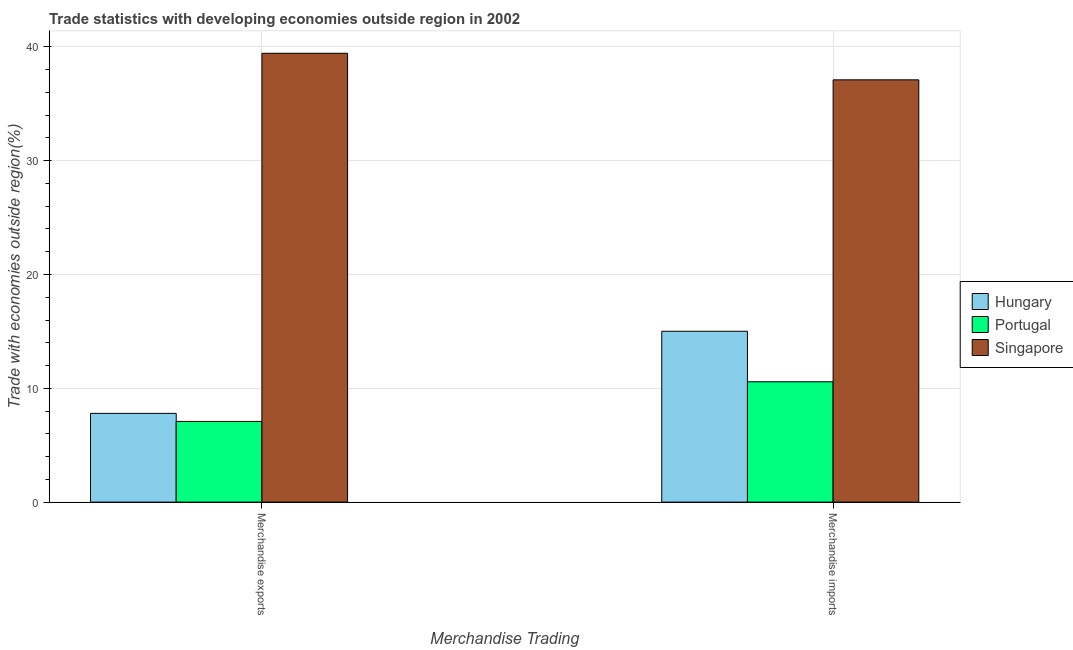How many groups of bars are there?
Keep it short and to the point. 2. Are the number of bars per tick equal to the number of legend labels?
Your answer should be very brief. Yes. How many bars are there on the 2nd tick from the left?
Provide a short and direct response. 3. How many bars are there on the 1st tick from the right?
Make the answer very short. 3. What is the merchandise exports in Hungary?
Your answer should be compact. 7.8. Across all countries, what is the maximum merchandise imports?
Make the answer very short. 37.1. Across all countries, what is the minimum merchandise imports?
Offer a very short reply. 10.57. In which country was the merchandise exports maximum?
Make the answer very short. Singapore. In which country was the merchandise exports minimum?
Your answer should be very brief. Portugal. What is the total merchandise imports in the graph?
Offer a very short reply. 62.69. What is the difference between the merchandise exports in Hungary and that in Portugal?
Offer a very short reply. 0.71. What is the difference between the merchandise imports in Portugal and the merchandise exports in Hungary?
Offer a terse response. 2.78. What is the average merchandise exports per country?
Make the answer very short. 18.11. What is the difference between the merchandise exports and merchandise imports in Hungary?
Ensure brevity in your answer.  -7.21. In how many countries, is the merchandise imports greater than 26 %?
Make the answer very short. 1. What is the ratio of the merchandise imports in Singapore to that in Portugal?
Keep it short and to the point. 3.51. Is the merchandise exports in Hungary less than that in Singapore?
Offer a terse response. Yes. In how many countries, is the merchandise exports greater than the average merchandise exports taken over all countries?
Ensure brevity in your answer.  1. What does the 1st bar from the left in Merchandise exports represents?
Offer a terse response. Hungary. How many bars are there?
Offer a very short reply. 6. Are all the bars in the graph horizontal?
Keep it short and to the point. No. How many countries are there in the graph?
Keep it short and to the point. 3. Are the values on the major ticks of Y-axis written in scientific E-notation?
Make the answer very short. No. Where does the legend appear in the graph?
Offer a terse response. Center right. What is the title of the graph?
Give a very brief answer. Trade statistics with developing economies outside region in 2002. Does "Isle of Man" appear as one of the legend labels in the graph?
Your answer should be compact. No. What is the label or title of the X-axis?
Make the answer very short. Merchandise Trading. What is the label or title of the Y-axis?
Your response must be concise. Trade with economies outside region(%). What is the Trade with economies outside region(%) in Hungary in Merchandise exports?
Your answer should be very brief. 7.8. What is the Trade with economies outside region(%) of Portugal in Merchandise exports?
Provide a succinct answer. 7.09. What is the Trade with economies outside region(%) of Singapore in Merchandise exports?
Offer a very short reply. 39.44. What is the Trade with economies outside region(%) of Hungary in Merchandise imports?
Offer a very short reply. 15.01. What is the Trade with economies outside region(%) of Portugal in Merchandise imports?
Give a very brief answer. 10.57. What is the Trade with economies outside region(%) in Singapore in Merchandise imports?
Give a very brief answer. 37.1. Across all Merchandise Trading, what is the maximum Trade with economies outside region(%) of Hungary?
Your answer should be very brief. 15.01. Across all Merchandise Trading, what is the maximum Trade with economies outside region(%) in Portugal?
Offer a very short reply. 10.57. Across all Merchandise Trading, what is the maximum Trade with economies outside region(%) in Singapore?
Your response must be concise. 39.44. Across all Merchandise Trading, what is the minimum Trade with economies outside region(%) of Hungary?
Provide a short and direct response. 7.8. Across all Merchandise Trading, what is the minimum Trade with economies outside region(%) of Portugal?
Provide a succinct answer. 7.09. Across all Merchandise Trading, what is the minimum Trade with economies outside region(%) in Singapore?
Ensure brevity in your answer.  37.1. What is the total Trade with economies outside region(%) of Hungary in the graph?
Keep it short and to the point. 22.81. What is the total Trade with economies outside region(%) in Portugal in the graph?
Keep it short and to the point. 17.66. What is the total Trade with economies outside region(%) of Singapore in the graph?
Offer a terse response. 76.54. What is the difference between the Trade with economies outside region(%) of Hungary in Merchandise exports and that in Merchandise imports?
Offer a very short reply. -7.21. What is the difference between the Trade with economies outside region(%) in Portugal in Merchandise exports and that in Merchandise imports?
Provide a succinct answer. -3.48. What is the difference between the Trade with economies outside region(%) in Singapore in Merchandise exports and that in Merchandise imports?
Keep it short and to the point. 2.33. What is the difference between the Trade with economies outside region(%) of Hungary in Merchandise exports and the Trade with economies outside region(%) of Portugal in Merchandise imports?
Your answer should be very brief. -2.78. What is the difference between the Trade with economies outside region(%) of Hungary in Merchandise exports and the Trade with economies outside region(%) of Singapore in Merchandise imports?
Give a very brief answer. -29.31. What is the difference between the Trade with economies outside region(%) of Portugal in Merchandise exports and the Trade with economies outside region(%) of Singapore in Merchandise imports?
Provide a succinct answer. -30.01. What is the average Trade with economies outside region(%) in Hungary per Merchandise Trading?
Your response must be concise. 11.4. What is the average Trade with economies outside region(%) in Portugal per Merchandise Trading?
Provide a succinct answer. 8.83. What is the average Trade with economies outside region(%) in Singapore per Merchandise Trading?
Your answer should be compact. 38.27. What is the difference between the Trade with economies outside region(%) of Hungary and Trade with economies outside region(%) of Portugal in Merchandise exports?
Your answer should be compact. 0.71. What is the difference between the Trade with economies outside region(%) in Hungary and Trade with economies outside region(%) in Singapore in Merchandise exports?
Your response must be concise. -31.64. What is the difference between the Trade with economies outside region(%) in Portugal and Trade with economies outside region(%) in Singapore in Merchandise exports?
Provide a short and direct response. -32.35. What is the difference between the Trade with economies outside region(%) of Hungary and Trade with economies outside region(%) of Portugal in Merchandise imports?
Give a very brief answer. 4.44. What is the difference between the Trade with economies outside region(%) in Hungary and Trade with economies outside region(%) in Singapore in Merchandise imports?
Keep it short and to the point. -22.09. What is the difference between the Trade with economies outside region(%) in Portugal and Trade with economies outside region(%) in Singapore in Merchandise imports?
Give a very brief answer. -26.53. What is the ratio of the Trade with economies outside region(%) of Hungary in Merchandise exports to that in Merchandise imports?
Offer a terse response. 0.52. What is the ratio of the Trade with economies outside region(%) in Portugal in Merchandise exports to that in Merchandise imports?
Your answer should be compact. 0.67. What is the ratio of the Trade with economies outside region(%) in Singapore in Merchandise exports to that in Merchandise imports?
Make the answer very short. 1.06. What is the difference between the highest and the second highest Trade with economies outside region(%) in Hungary?
Your response must be concise. 7.21. What is the difference between the highest and the second highest Trade with economies outside region(%) of Portugal?
Your answer should be very brief. 3.48. What is the difference between the highest and the second highest Trade with economies outside region(%) of Singapore?
Your answer should be very brief. 2.33. What is the difference between the highest and the lowest Trade with economies outside region(%) in Hungary?
Provide a succinct answer. 7.21. What is the difference between the highest and the lowest Trade with economies outside region(%) in Portugal?
Your answer should be compact. 3.48. What is the difference between the highest and the lowest Trade with economies outside region(%) of Singapore?
Your answer should be compact. 2.33. 